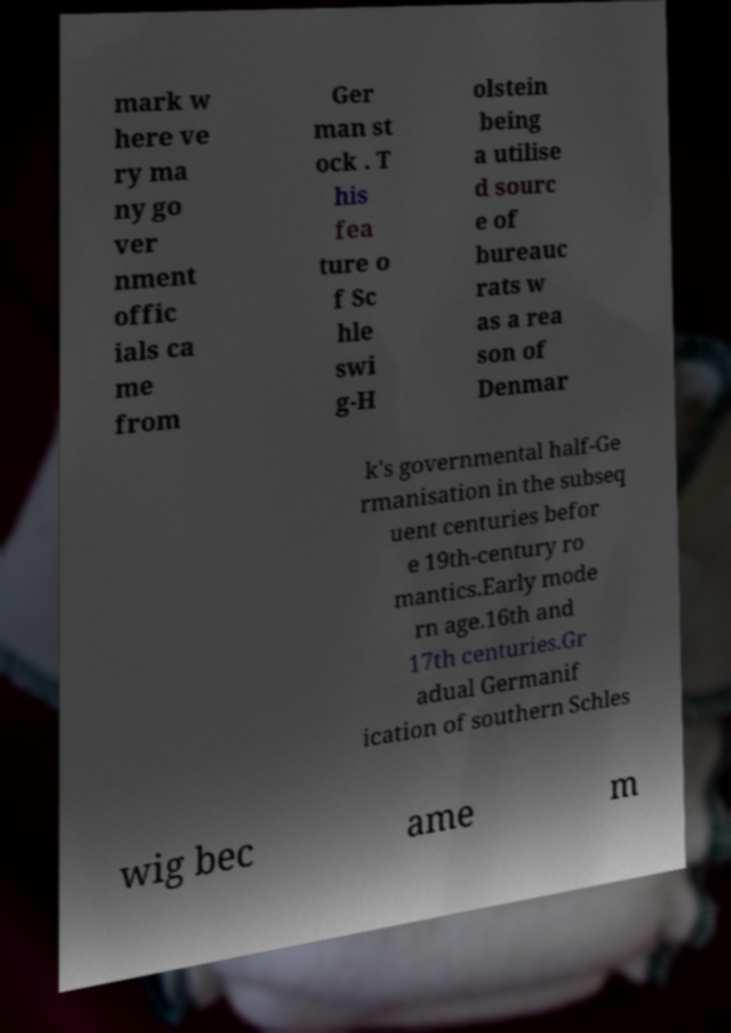Please identify and transcribe the text found in this image. mark w here ve ry ma ny go ver nment offic ials ca me from Ger man st ock . T his fea ture o f Sc hle swi g-H olstein being a utilise d sourc e of bureauc rats w as a rea son of Denmar k's governmental half-Ge rmanisation in the subseq uent centuries befor e 19th-century ro mantics.Early mode rn age.16th and 17th centuries.Gr adual Germanif ication of southern Schles wig bec ame m 